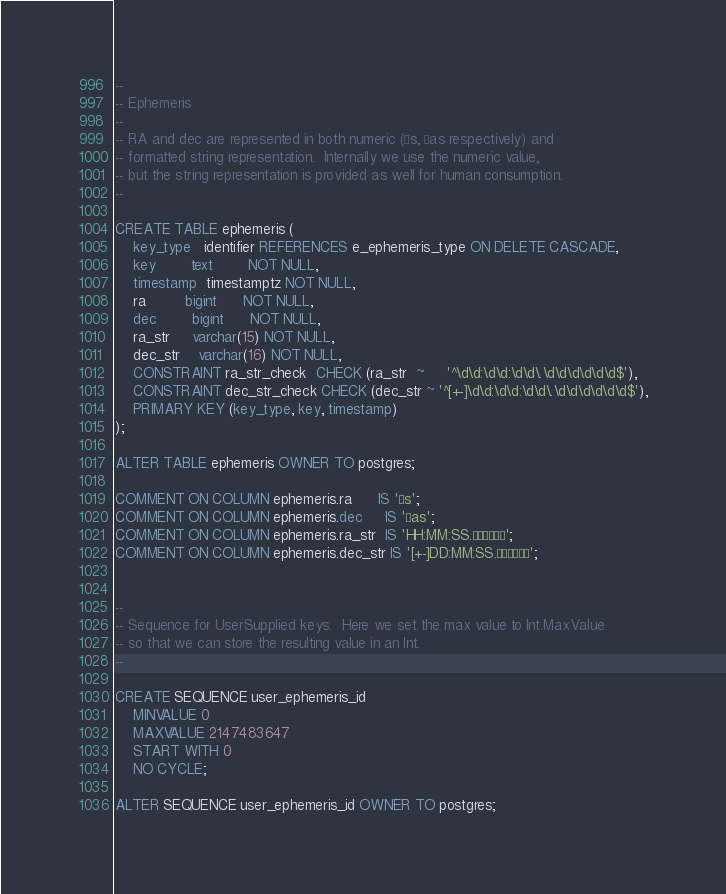Convert code to text. <code><loc_0><loc_0><loc_500><loc_500><_SQL_>
--
-- Ephemeris
--
-- RA and dec are represented in both numeric (µs, µas respectively) and
-- formatted string representation.  Internally we use the numeric value,
-- but the string representation is provided as well for human consumption.
--

CREATE TABLE ephemeris (
    key_type   identifier REFERENCES e_ephemeris_type ON DELETE CASCADE,
    key        text        NOT NULL,
    timestamp  timestamptz NOT NULL,
    ra         bigint      NOT NULL,
    dec        bigint      NOT NULL,
    ra_str     varchar(15) NOT NULL,
    dec_str    varchar(16) NOT NULL,
    CONSTRAINT ra_str_check  CHECK (ra_str  ~     '^\d\d:\d\d:\d\d\.\d\d\d\d\d\d$'),
    CONSTRAINT dec_str_check CHECK (dec_str ~ '^[+-]\d\d:\d\d:\d\d\.\d\d\d\d\d\d$'),
    PRIMARY KEY (key_type, key, timestamp)
);

ALTER TABLE ephemeris OWNER TO postgres;

COMMENT ON COLUMN ephemeris.ra      IS 'µs';
COMMENT ON COLUMN ephemeris.dec     IS 'µas';
COMMENT ON COLUMN ephemeris.ra_str  IS 'HH:MM:SS.µµµµµµ';
COMMENT ON COLUMN ephemeris.dec_str IS '[+-]DD:MM:SS.µµµµµµ';


--
-- Sequence for UserSupplied keys.  Here we set the max value to Int.MaxValue
-- so that we can store the resulting value in an Int.
--

CREATE SEQUENCE user_ephemeris_id
    MINVALUE 0
    MAXVALUE 2147483647
    START WITH 0
    NO CYCLE;

ALTER SEQUENCE user_ephemeris_id OWNER TO postgres;
</code> 